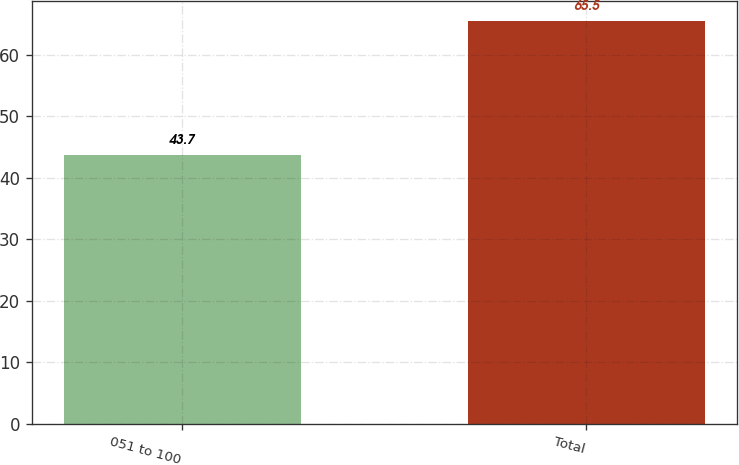<chart> <loc_0><loc_0><loc_500><loc_500><bar_chart><fcel>051 to 100<fcel>Total<nl><fcel>43.7<fcel>65.5<nl></chart> 